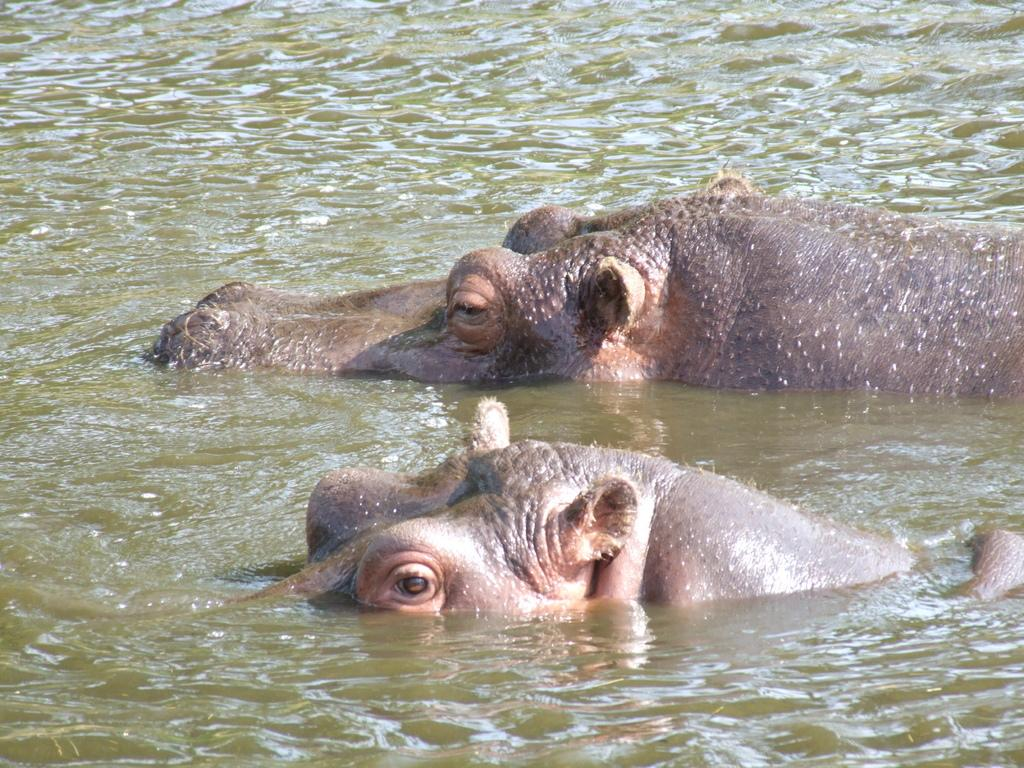What animals are present in the image? There are two rhinos in the image. Where are the rhinos located in the image? The rhinos are in the water. What type of playground equipment can be seen in the image? There is no playground equipment present in the image; it features two rhinos in the water. What knowledge can be gained from the image about the history of aviation? The image does not provide any information about the history of aviation, as it features two rhinos in the water. 